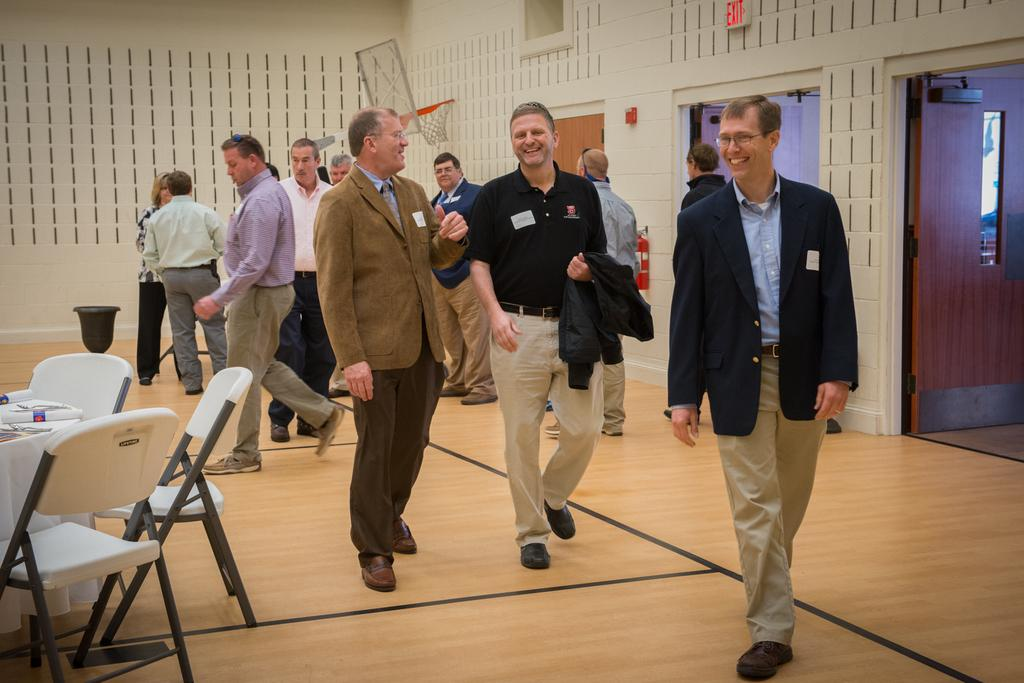What can be seen in the image in terms of human presence? There are people standing in the image. What type of furniture is present in the image? There are chairs and tables in the image. Can you describe the expressions of some people in the image? Some people in the image are smiling. How many zippers can be seen on the people in the image? There are no zippers visible on the people in the image. What achievements have the smiling people in the image accomplished? The image does not provide information about the achievements of the smiling people. 